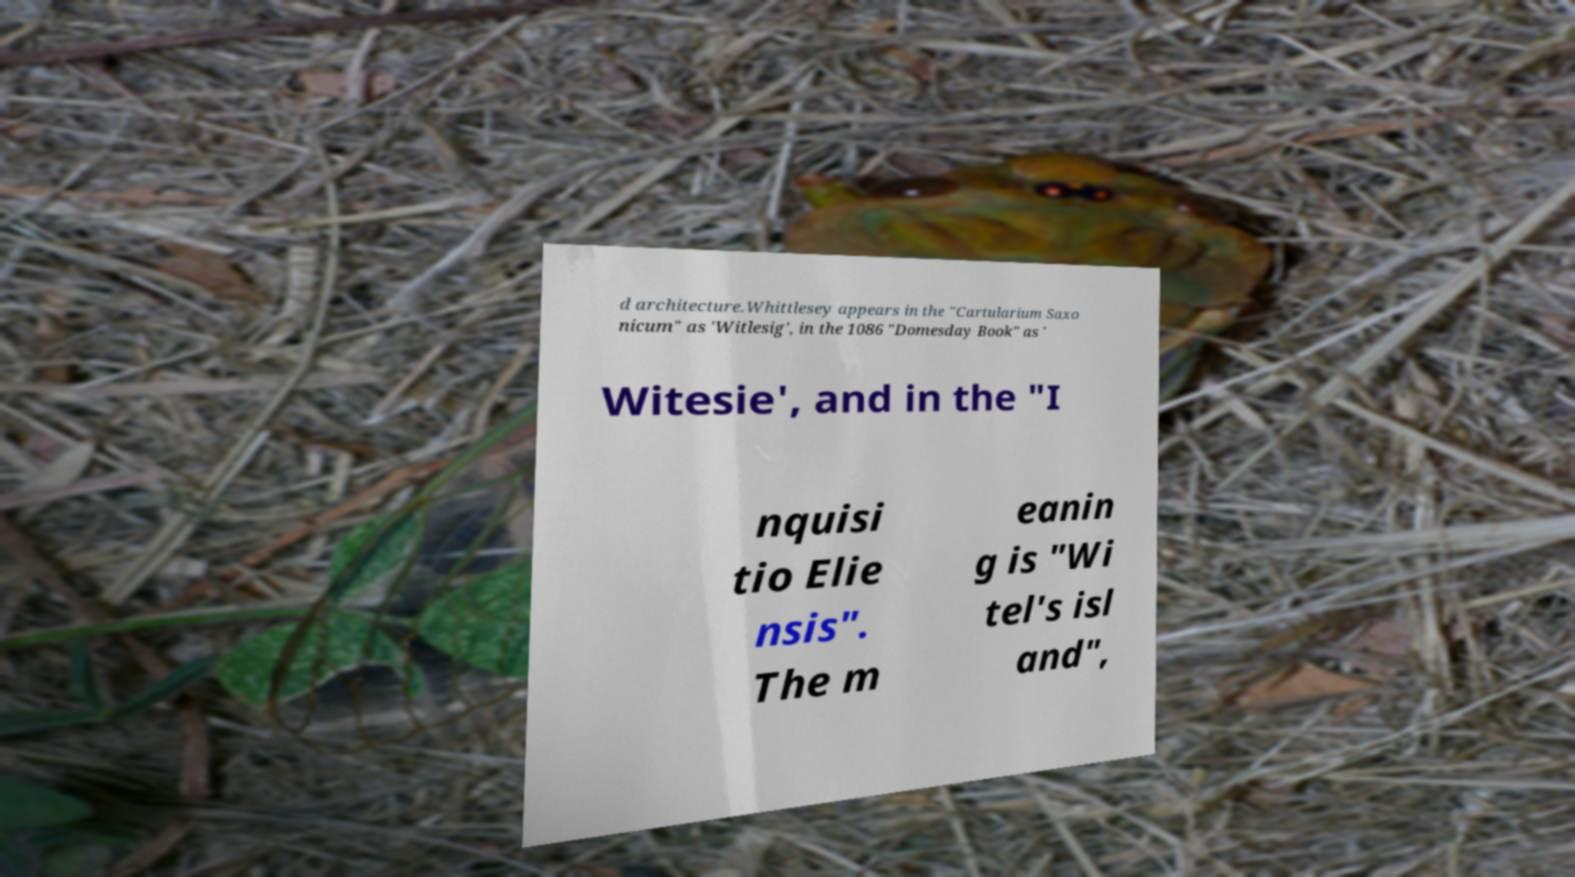Could you extract and type out the text from this image? d architecture.Whittlesey appears in the "Cartularium Saxo nicum" as 'Witlesig', in the 1086 "Domesday Book" as ' Witesie', and in the "I nquisi tio Elie nsis". The m eanin g is "Wi tel's isl and", 